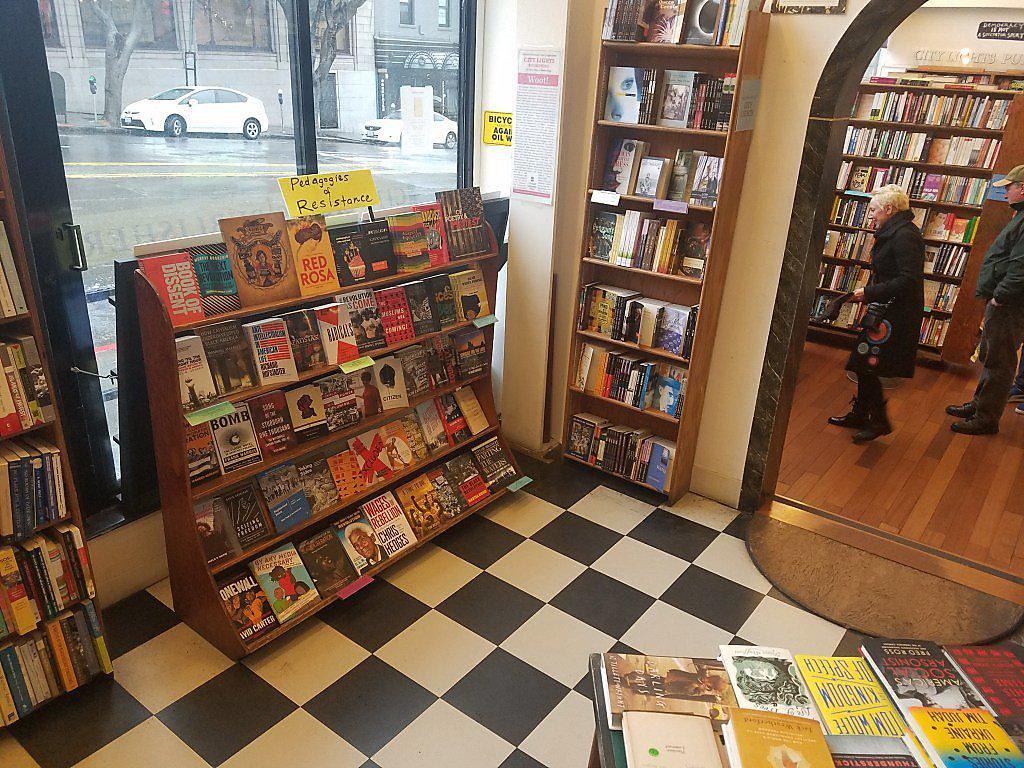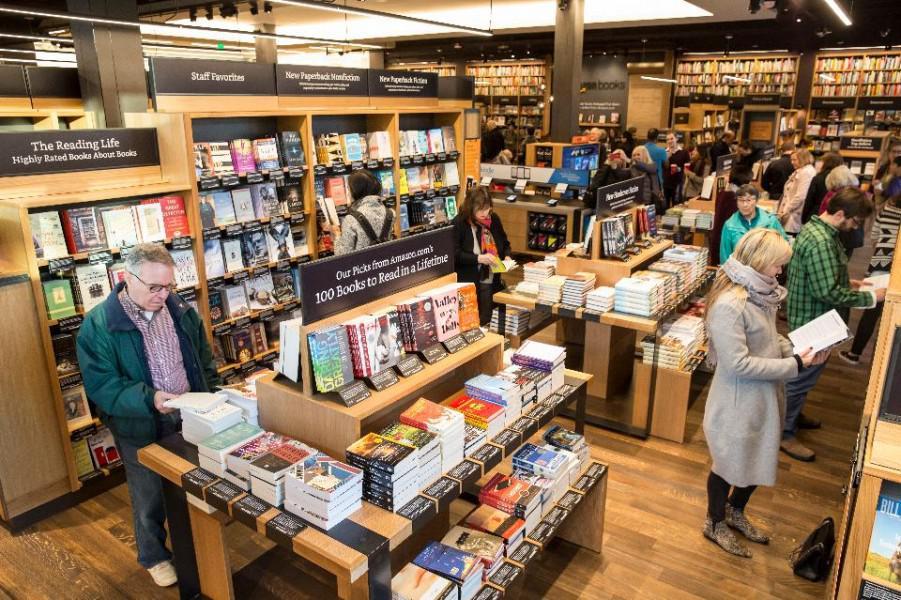The first image is the image on the left, the second image is the image on the right. Analyze the images presented: Is the assertion "There is at least one person in the image on the left." valid? Answer yes or no. Yes. 